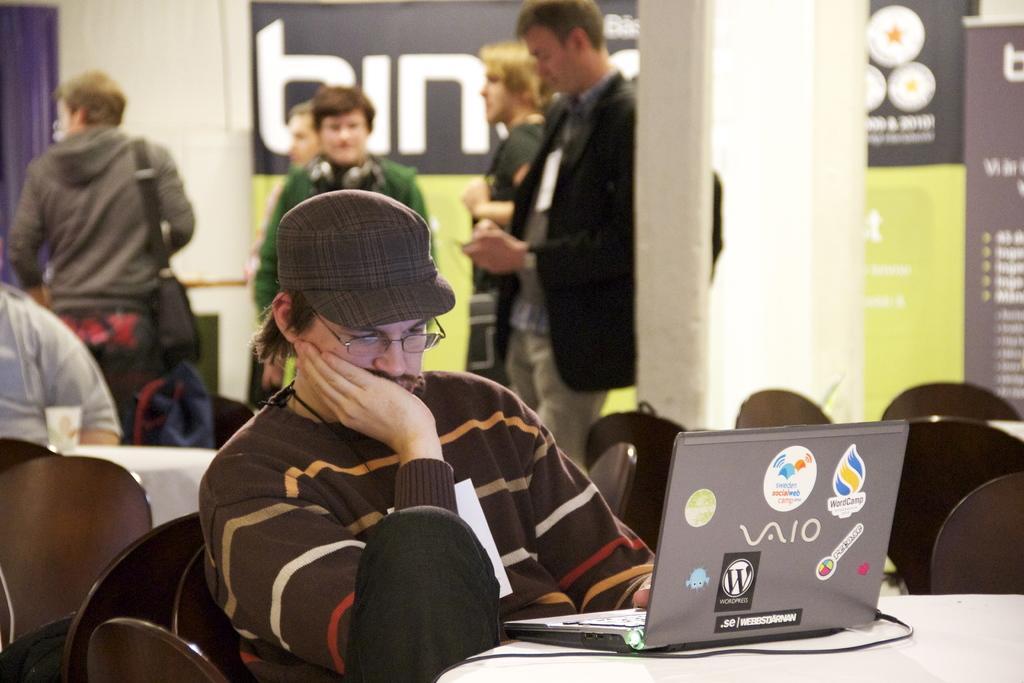How would you summarize this image in a sentence or two? In this image we can see a man sitting on the chair and holding a laptop that is placed on the table. In the background there are persons sitting on the chairs and standing on the floor. 